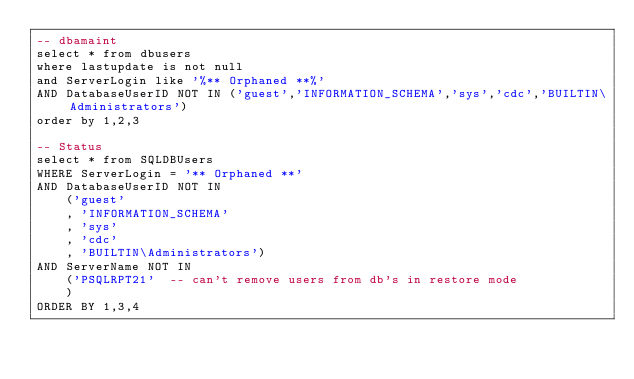Convert code to text. <code><loc_0><loc_0><loc_500><loc_500><_SQL_>-- dbamaint
select * from dbusers 
where lastupdate is not null  
and ServerLogin like '%** Orphaned **%'
AND DatabaseUserID NOT IN ('guest','INFORMATION_SCHEMA','sys','cdc','BUILTIN\Administrators')  
order by 1,2,3

-- Status
select * from SQLDBUsers
WHERE ServerLogin = '** Orphaned **'
AND DatabaseUserID NOT IN 
	('guest'
	, 'INFORMATION_SCHEMA'
	, 'sys'
	, 'cdc'
	, 'BUILTIN\Administrators')
AND ServerName NOT IN 
	('PSQLRPT21'  -- can't remove users from db's in restore mode
	)
ORDER BY 1,3,4

</code> 